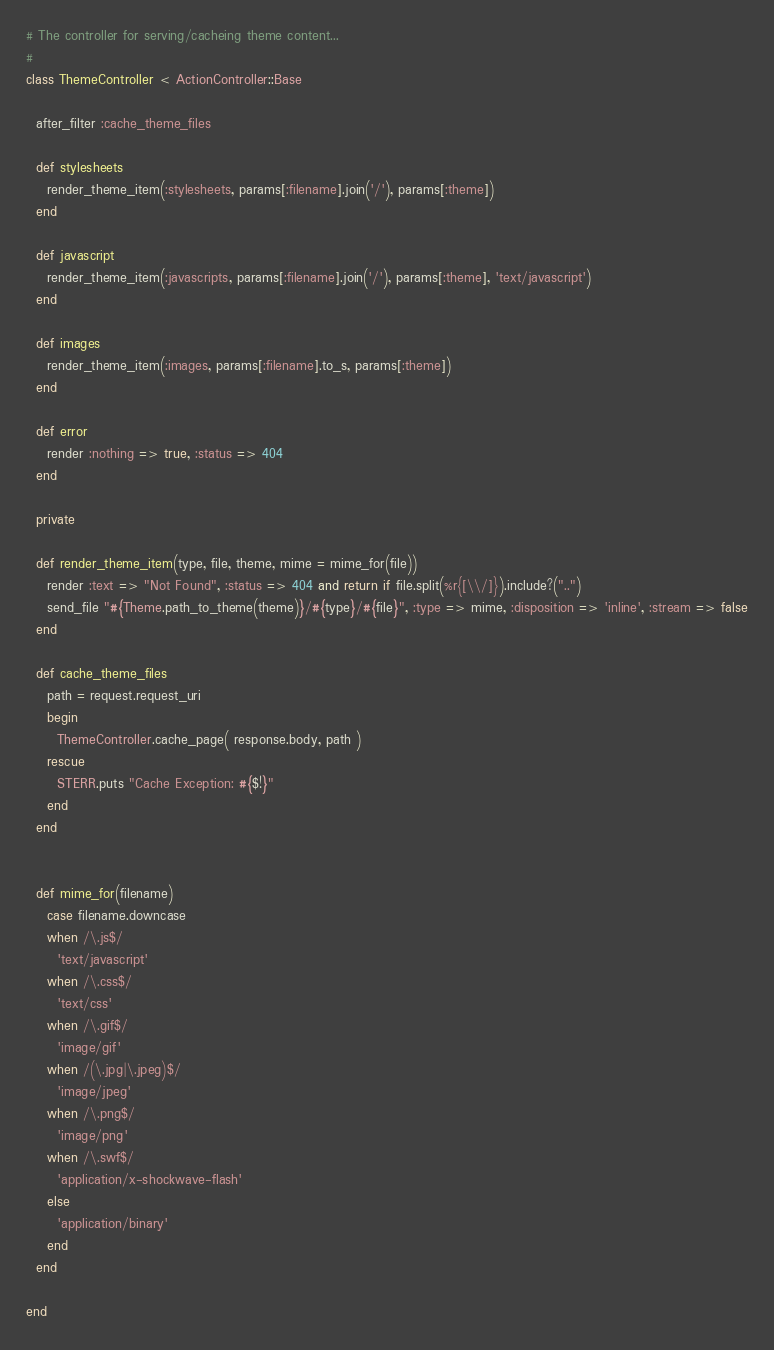<code> <loc_0><loc_0><loc_500><loc_500><_Ruby_># The controller for serving/cacheing theme content...
#
class ThemeController < ActionController::Base

  after_filter :cache_theme_files
  
  def stylesheets
    render_theme_item(:stylesheets, params[:filename].join('/'), params[:theme])
  end

  def javascript
    render_theme_item(:javascripts, params[:filename].join('/'), params[:theme], 'text/javascript')
  end

  def images
    render_theme_item(:images, params[:filename].to_s, params[:theme])
  end

  def error
    render :nothing => true, :status => 404
  end
  
  private
  
  def render_theme_item(type, file, theme, mime = mime_for(file))
    render :text => "Not Found", :status => 404 and return if file.split(%r{[\\/]}).include?("..")
    send_file "#{Theme.path_to_theme(theme)}/#{type}/#{file}", :type => mime, :disposition => 'inline', :stream => false
  end

  def cache_theme_files
    path = request.request_uri
    begin
      ThemeController.cache_page( response.body, path )
    rescue
      STERR.puts "Cache Exception: #{$!}"
    end
  end

    
  def mime_for(filename)
    case filename.downcase
    when /\.js$/
      'text/javascript'
    when /\.css$/
      'text/css'
    when /\.gif$/
      'image/gif'
    when /(\.jpg|\.jpeg)$/
      'image/jpeg'
    when /\.png$/
      'image/png'
    when /\.swf$/
      'application/x-shockwave-flash'
    else
      'application/binary'
    end
  end  

end


</code> 